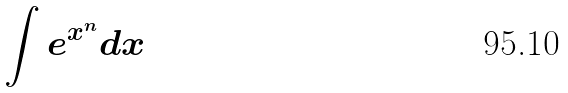Convert formula to latex. <formula><loc_0><loc_0><loc_500><loc_500>\int e ^ { x ^ { n } } d x</formula> 